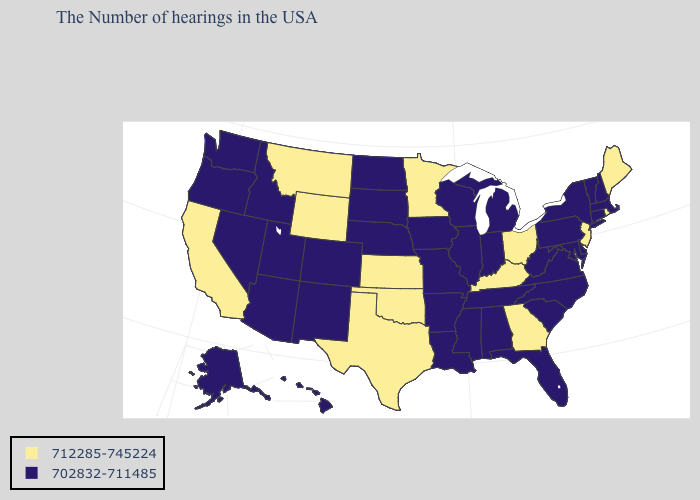Name the states that have a value in the range 702832-711485?
Quick response, please. Massachusetts, New Hampshire, Vermont, Connecticut, New York, Delaware, Maryland, Pennsylvania, Virginia, North Carolina, South Carolina, West Virginia, Florida, Michigan, Indiana, Alabama, Tennessee, Wisconsin, Illinois, Mississippi, Louisiana, Missouri, Arkansas, Iowa, Nebraska, South Dakota, North Dakota, Colorado, New Mexico, Utah, Arizona, Idaho, Nevada, Washington, Oregon, Alaska, Hawaii. Does Washington have the same value as South Carolina?
Be succinct. Yes. What is the value of California?
Be succinct. 712285-745224. What is the lowest value in the USA?
Write a very short answer. 702832-711485. Which states have the lowest value in the USA?
Quick response, please. Massachusetts, New Hampshire, Vermont, Connecticut, New York, Delaware, Maryland, Pennsylvania, Virginia, North Carolina, South Carolina, West Virginia, Florida, Michigan, Indiana, Alabama, Tennessee, Wisconsin, Illinois, Mississippi, Louisiana, Missouri, Arkansas, Iowa, Nebraska, South Dakota, North Dakota, Colorado, New Mexico, Utah, Arizona, Idaho, Nevada, Washington, Oregon, Alaska, Hawaii. What is the lowest value in the Northeast?
Quick response, please. 702832-711485. Among the states that border Colorado , which have the highest value?
Be succinct. Kansas, Oklahoma, Wyoming. Name the states that have a value in the range 702832-711485?
Answer briefly. Massachusetts, New Hampshire, Vermont, Connecticut, New York, Delaware, Maryland, Pennsylvania, Virginia, North Carolina, South Carolina, West Virginia, Florida, Michigan, Indiana, Alabama, Tennessee, Wisconsin, Illinois, Mississippi, Louisiana, Missouri, Arkansas, Iowa, Nebraska, South Dakota, North Dakota, Colorado, New Mexico, Utah, Arizona, Idaho, Nevada, Washington, Oregon, Alaska, Hawaii. What is the value of Minnesota?
Be succinct. 712285-745224. Which states have the highest value in the USA?
Answer briefly. Maine, Rhode Island, New Jersey, Ohio, Georgia, Kentucky, Minnesota, Kansas, Oklahoma, Texas, Wyoming, Montana, California. Name the states that have a value in the range 712285-745224?
Short answer required. Maine, Rhode Island, New Jersey, Ohio, Georgia, Kentucky, Minnesota, Kansas, Oklahoma, Texas, Wyoming, Montana, California. What is the highest value in states that border Connecticut?
Keep it brief. 712285-745224. What is the lowest value in states that border Montana?
Quick response, please. 702832-711485. What is the value of Wyoming?
Give a very brief answer. 712285-745224. Does Vermont have the lowest value in the USA?
Write a very short answer. Yes. 